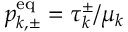<formula> <loc_0><loc_0><loc_500><loc_500>p _ { k , \pm } ^ { e q } = \tau _ { k } ^ { \pm } / \mu _ { k }</formula> 